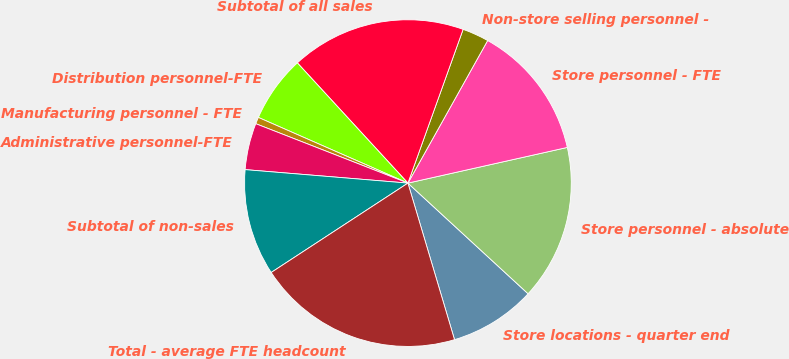Convert chart. <chart><loc_0><loc_0><loc_500><loc_500><pie_chart><fcel>Store locations - quarter end<fcel>Store personnel - absolute<fcel>Store personnel - FTE<fcel>Non-store selling personnel -<fcel>Subtotal of all sales<fcel>Distribution personnel-FTE<fcel>Manufacturing personnel - FTE<fcel>Administrative personnel-FTE<fcel>Subtotal of non-sales<fcel>Total - average FTE headcount<nl><fcel>8.55%<fcel>15.35%<fcel>13.38%<fcel>2.63%<fcel>17.32%<fcel>6.58%<fcel>0.66%<fcel>4.61%<fcel>10.53%<fcel>20.39%<nl></chart> 